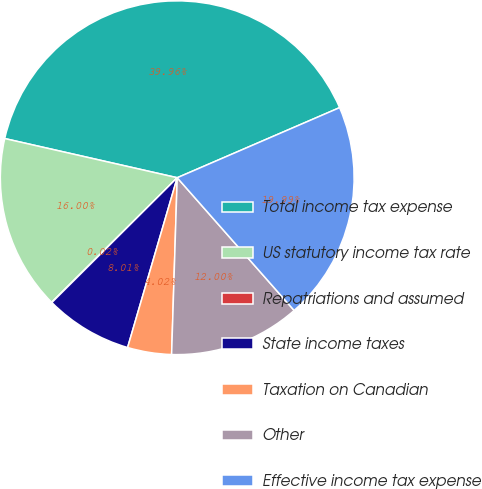Convert chart to OTSL. <chart><loc_0><loc_0><loc_500><loc_500><pie_chart><fcel>Total income tax expense<fcel>US statutory income tax rate<fcel>Repatriations and assumed<fcel>State income taxes<fcel>Taxation on Canadian<fcel>Other<fcel>Effective income tax expense<nl><fcel>39.96%<fcel>16.0%<fcel>0.02%<fcel>8.01%<fcel>4.02%<fcel>12.0%<fcel>19.99%<nl></chart> 